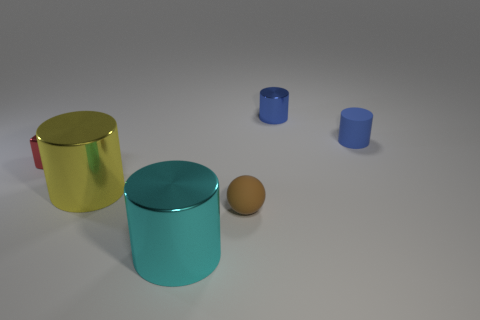What material is the other tiny cylinder that is the same color as the small rubber cylinder?
Make the answer very short. Metal. Is there a cyan rubber cube of the same size as the blue shiny object?
Your response must be concise. No. Is there a matte cylinder of the same color as the matte ball?
Ensure brevity in your answer.  No. Is there any other thing that is the same size as the brown ball?
Make the answer very short. Yes. What number of large shiny cylinders are the same color as the small sphere?
Your response must be concise. 0. Does the matte sphere have the same color as the tiny object that is left of the yellow shiny object?
Offer a terse response. No. What number of things are tiny brown balls or objects that are on the left side of the blue shiny cylinder?
Your answer should be compact. 4. How big is the shiny cylinder that is on the right side of the large thing to the right of the yellow shiny cylinder?
Your answer should be very brief. Small. Are there the same number of large metal things in front of the yellow shiny cylinder and small brown things to the right of the small blue rubber cylinder?
Keep it short and to the point. No. There is a small thing right of the tiny blue shiny cylinder; are there any large cylinders that are to the right of it?
Your answer should be very brief. No. 